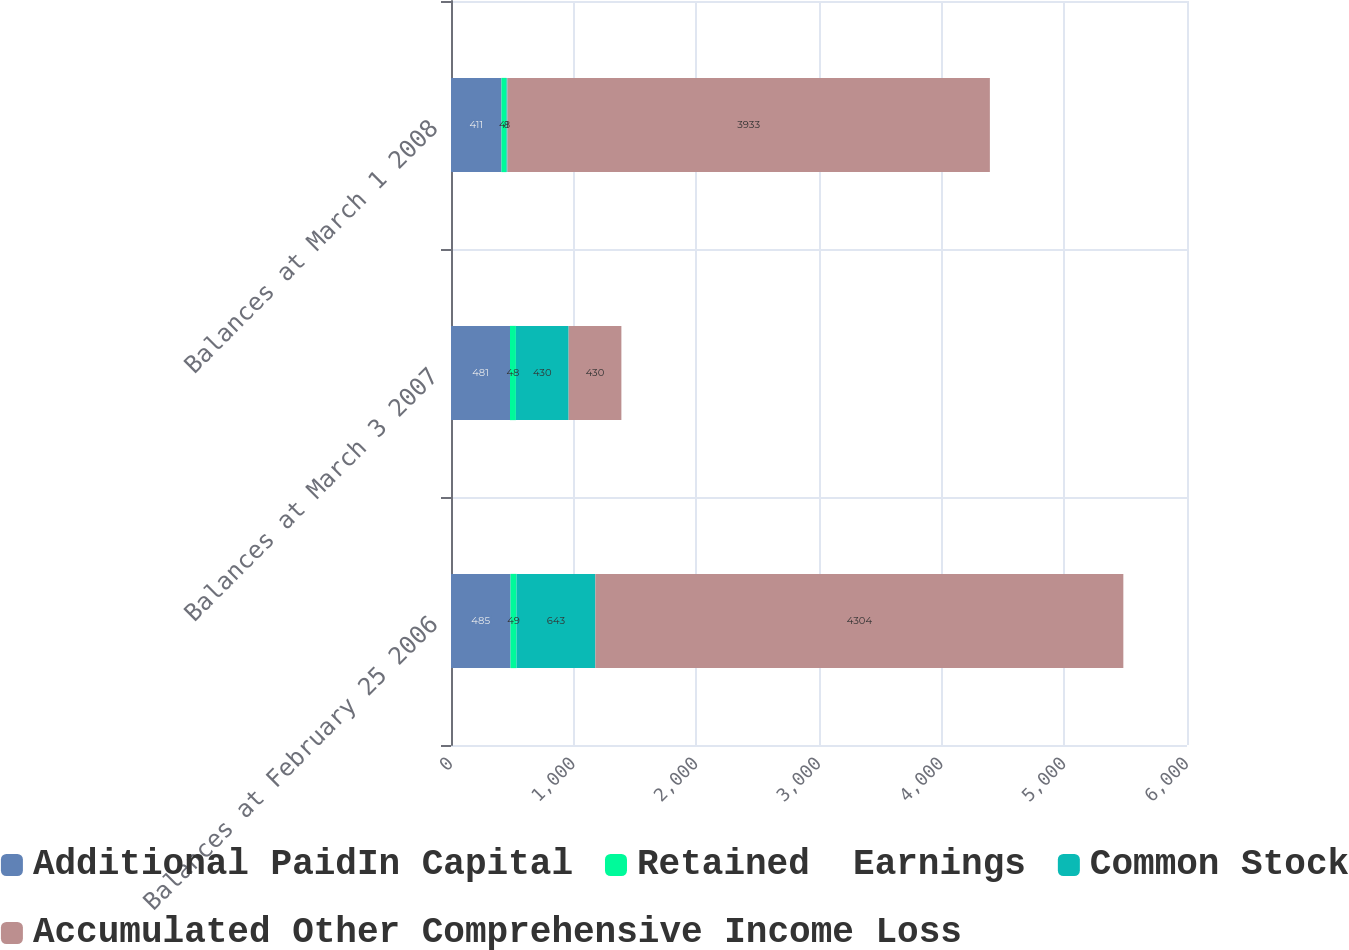Convert chart. <chart><loc_0><loc_0><loc_500><loc_500><stacked_bar_chart><ecel><fcel>Balances at February 25 2006<fcel>Balances at March 3 2007<fcel>Balances at March 1 2008<nl><fcel>Additional PaidIn Capital<fcel>485<fcel>481<fcel>411<nl><fcel>Retained  Earnings<fcel>49<fcel>48<fcel>41<nl><fcel>Common Stock<fcel>643<fcel>430<fcel>8<nl><fcel>Accumulated Other Comprehensive Income Loss<fcel>4304<fcel>430<fcel>3933<nl></chart> 